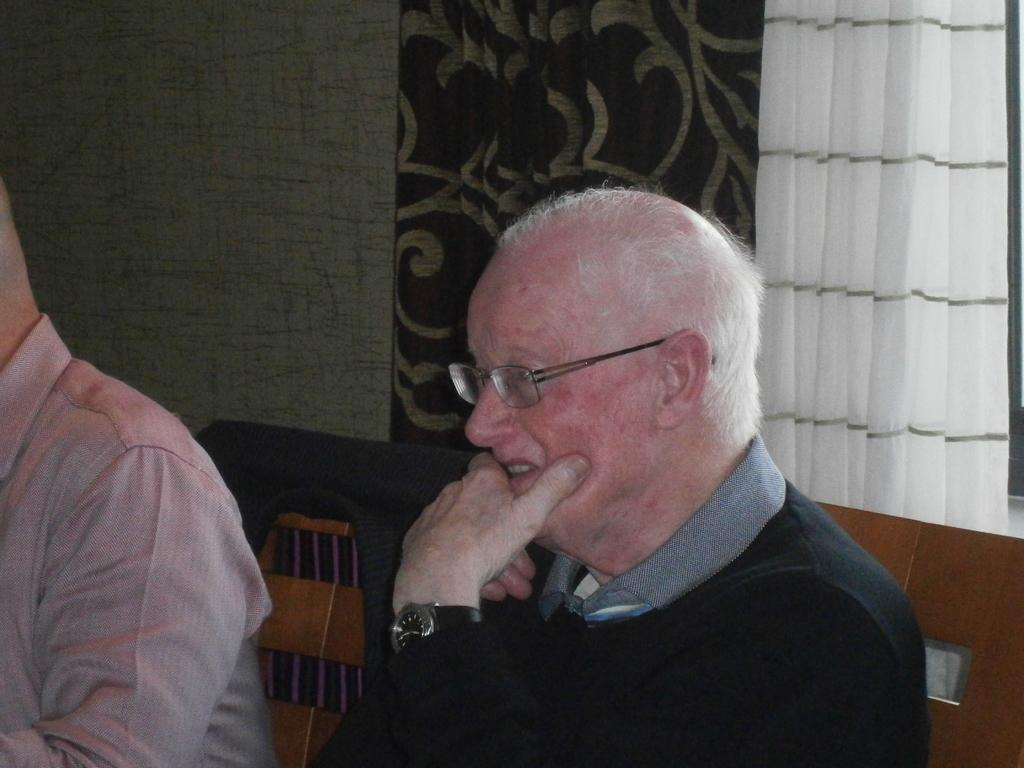What are the people in the image doing? The people in the image are sitting on chairs. Can you describe any specific features of one of the people? One of the people is wearing glasses. What can be seen in the background of the image? There is a wall and curtains visible in the background of the image. How many men are holding rabbits in the image? There are no men or rabbits present in the image. What type of cat can be seen sitting on the chair next to the person wearing glasses? There is no cat present in the image. 